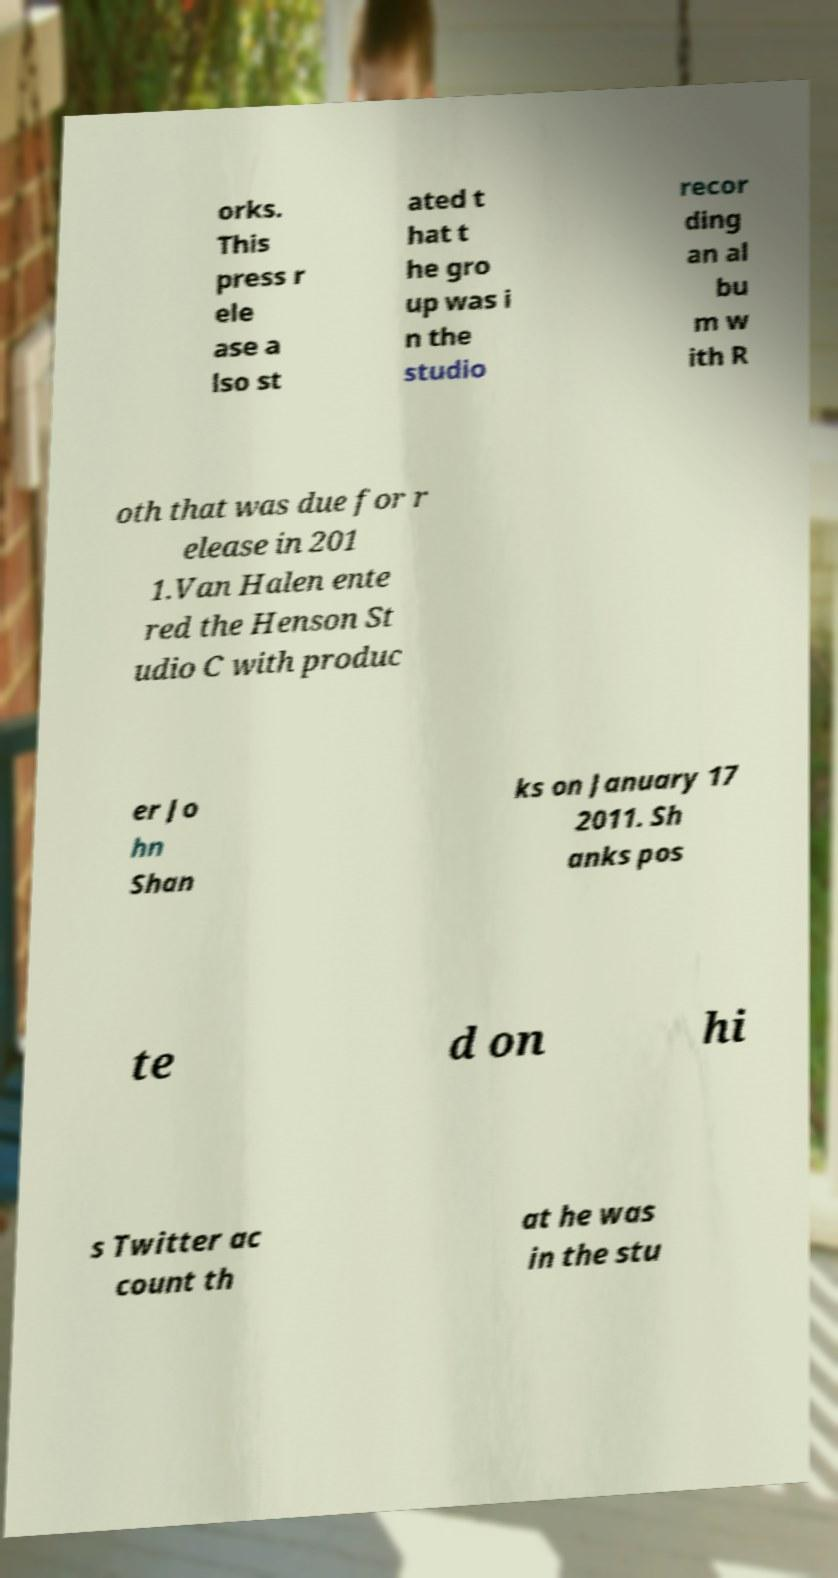Could you assist in decoding the text presented in this image and type it out clearly? orks. This press r ele ase a lso st ated t hat t he gro up was i n the studio recor ding an al bu m w ith R oth that was due for r elease in 201 1.Van Halen ente red the Henson St udio C with produc er Jo hn Shan ks on January 17 2011. Sh anks pos te d on hi s Twitter ac count th at he was in the stu 